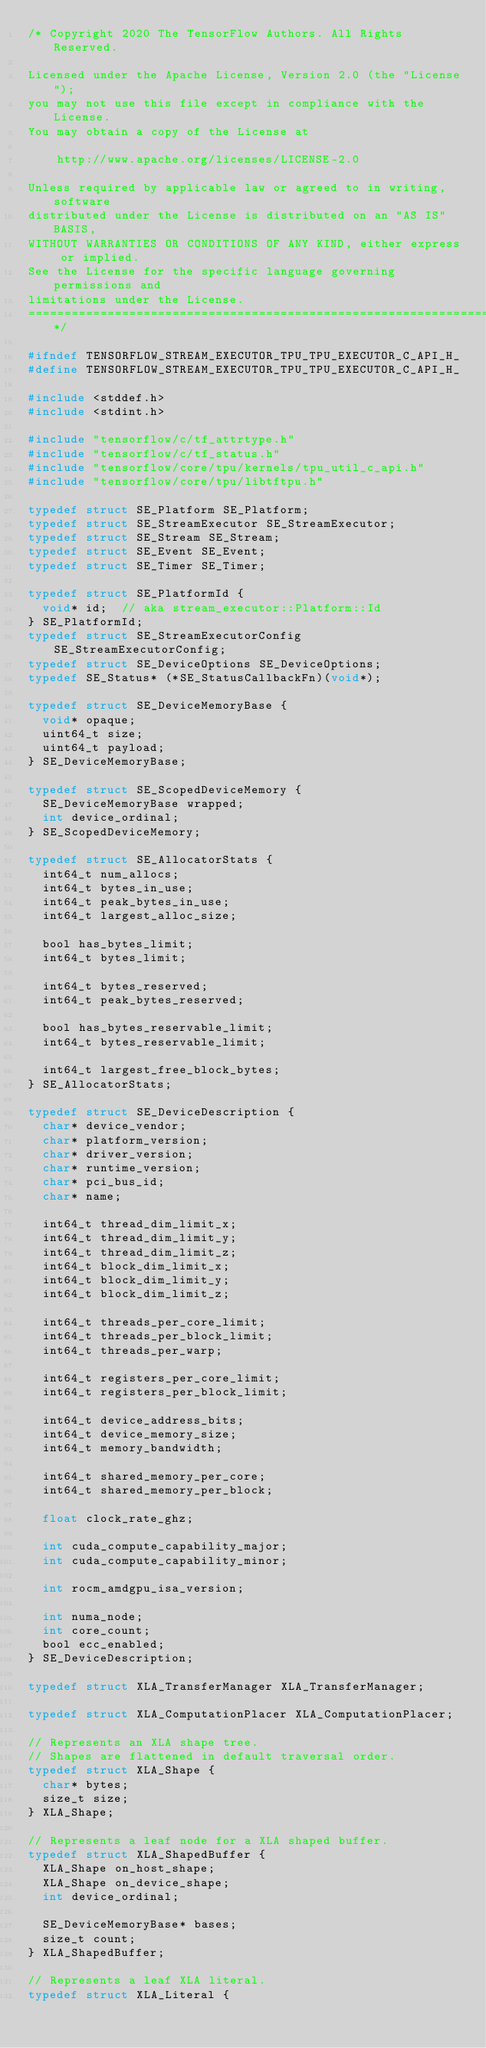<code> <loc_0><loc_0><loc_500><loc_500><_C_>/* Copyright 2020 The TensorFlow Authors. All Rights Reserved.

Licensed under the Apache License, Version 2.0 (the "License");
you may not use this file except in compliance with the License.
You may obtain a copy of the License at

    http://www.apache.org/licenses/LICENSE-2.0

Unless required by applicable law or agreed to in writing, software
distributed under the License is distributed on an "AS IS" BASIS,
WITHOUT WARRANTIES OR CONDITIONS OF ANY KIND, either express or implied.
See the License for the specific language governing permissions and
limitations under the License.
==============================================================================*/

#ifndef TENSORFLOW_STREAM_EXECUTOR_TPU_TPU_EXECUTOR_C_API_H_
#define TENSORFLOW_STREAM_EXECUTOR_TPU_TPU_EXECUTOR_C_API_H_

#include <stddef.h>
#include <stdint.h>

#include "tensorflow/c/tf_attrtype.h"
#include "tensorflow/c/tf_status.h"
#include "tensorflow/core/tpu/kernels/tpu_util_c_api.h"
#include "tensorflow/core/tpu/libtftpu.h"

typedef struct SE_Platform SE_Platform;
typedef struct SE_StreamExecutor SE_StreamExecutor;
typedef struct SE_Stream SE_Stream;
typedef struct SE_Event SE_Event;
typedef struct SE_Timer SE_Timer;

typedef struct SE_PlatformId {
  void* id;  // aka stream_executor::Platform::Id
} SE_PlatformId;
typedef struct SE_StreamExecutorConfig SE_StreamExecutorConfig;
typedef struct SE_DeviceOptions SE_DeviceOptions;
typedef SE_Status* (*SE_StatusCallbackFn)(void*);

typedef struct SE_DeviceMemoryBase {
  void* opaque;
  uint64_t size;
  uint64_t payload;
} SE_DeviceMemoryBase;

typedef struct SE_ScopedDeviceMemory {
  SE_DeviceMemoryBase wrapped;
  int device_ordinal;
} SE_ScopedDeviceMemory;

typedef struct SE_AllocatorStats {
  int64_t num_allocs;
  int64_t bytes_in_use;
  int64_t peak_bytes_in_use;
  int64_t largest_alloc_size;

  bool has_bytes_limit;
  int64_t bytes_limit;

  int64_t bytes_reserved;
  int64_t peak_bytes_reserved;

  bool has_bytes_reservable_limit;
  int64_t bytes_reservable_limit;

  int64_t largest_free_block_bytes;
} SE_AllocatorStats;

typedef struct SE_DeviceDescription {
  char* device_vendor;
  char* platform_version;
  char* driver_version;
  char* runtime_version;
  char* pci_bus_id;
  char* name;

  int64_t thread_dim_limit_x;
  int64_t thread_dim_limit_y;
  int64_t thread_dim_limit_z;
  int64_t block_dim_limit_x;
  int64_t block_dim_limit_y;
  int64_t block_dim_limit_z;

  int64_t threads_per_core_limit;
  int64_t threads_per_block_limit;
  int64_t threads_per_warp;

  int64_t registers_per_core_limit;
  int64_t registers_per_block_limit;

  int64_t device_address_bits;
  int64_t device_memory_size;
  int64_t memory_bandwidth;

  int64_t shared_memory_per_core;
  int64_t shared_memory_per_block;

  float clock_rate_ghz;

  int cuda_compute_capability_major;
  int cuda_compute_capability_minor;

  int rocm_amdgpu_isa_version;

  int numa_node;
  int core_count;
  bool ecc_enabled;
} SE_DeviceDescription;

typedef struct XLA_TransferManager XLA_TransferManager;

typedef struct XLA_ComputationPlacer XLA_ComputationPlacer;

// Represents an XLA shape tree.
// Shapes are flattened in default traversal order.
typedef struct XLA_Shape {
  char* bytes;
  size_t size;
} XLA_Shape;

// Represents a leaf node for a XLA shaped buffer.
typedef struct XLA_ShapedBuffer {
  XLA_Shape on_host_shape;
  XLA_Shape on_device_shape;
  int device_ordinal;

  SE_DeviceMemoryBase* bases;
  size_t count;
} XLA_ShapedBuffer;

// Represents a leaf XLA literal.
typedef struct XLA_Literal {</code> 